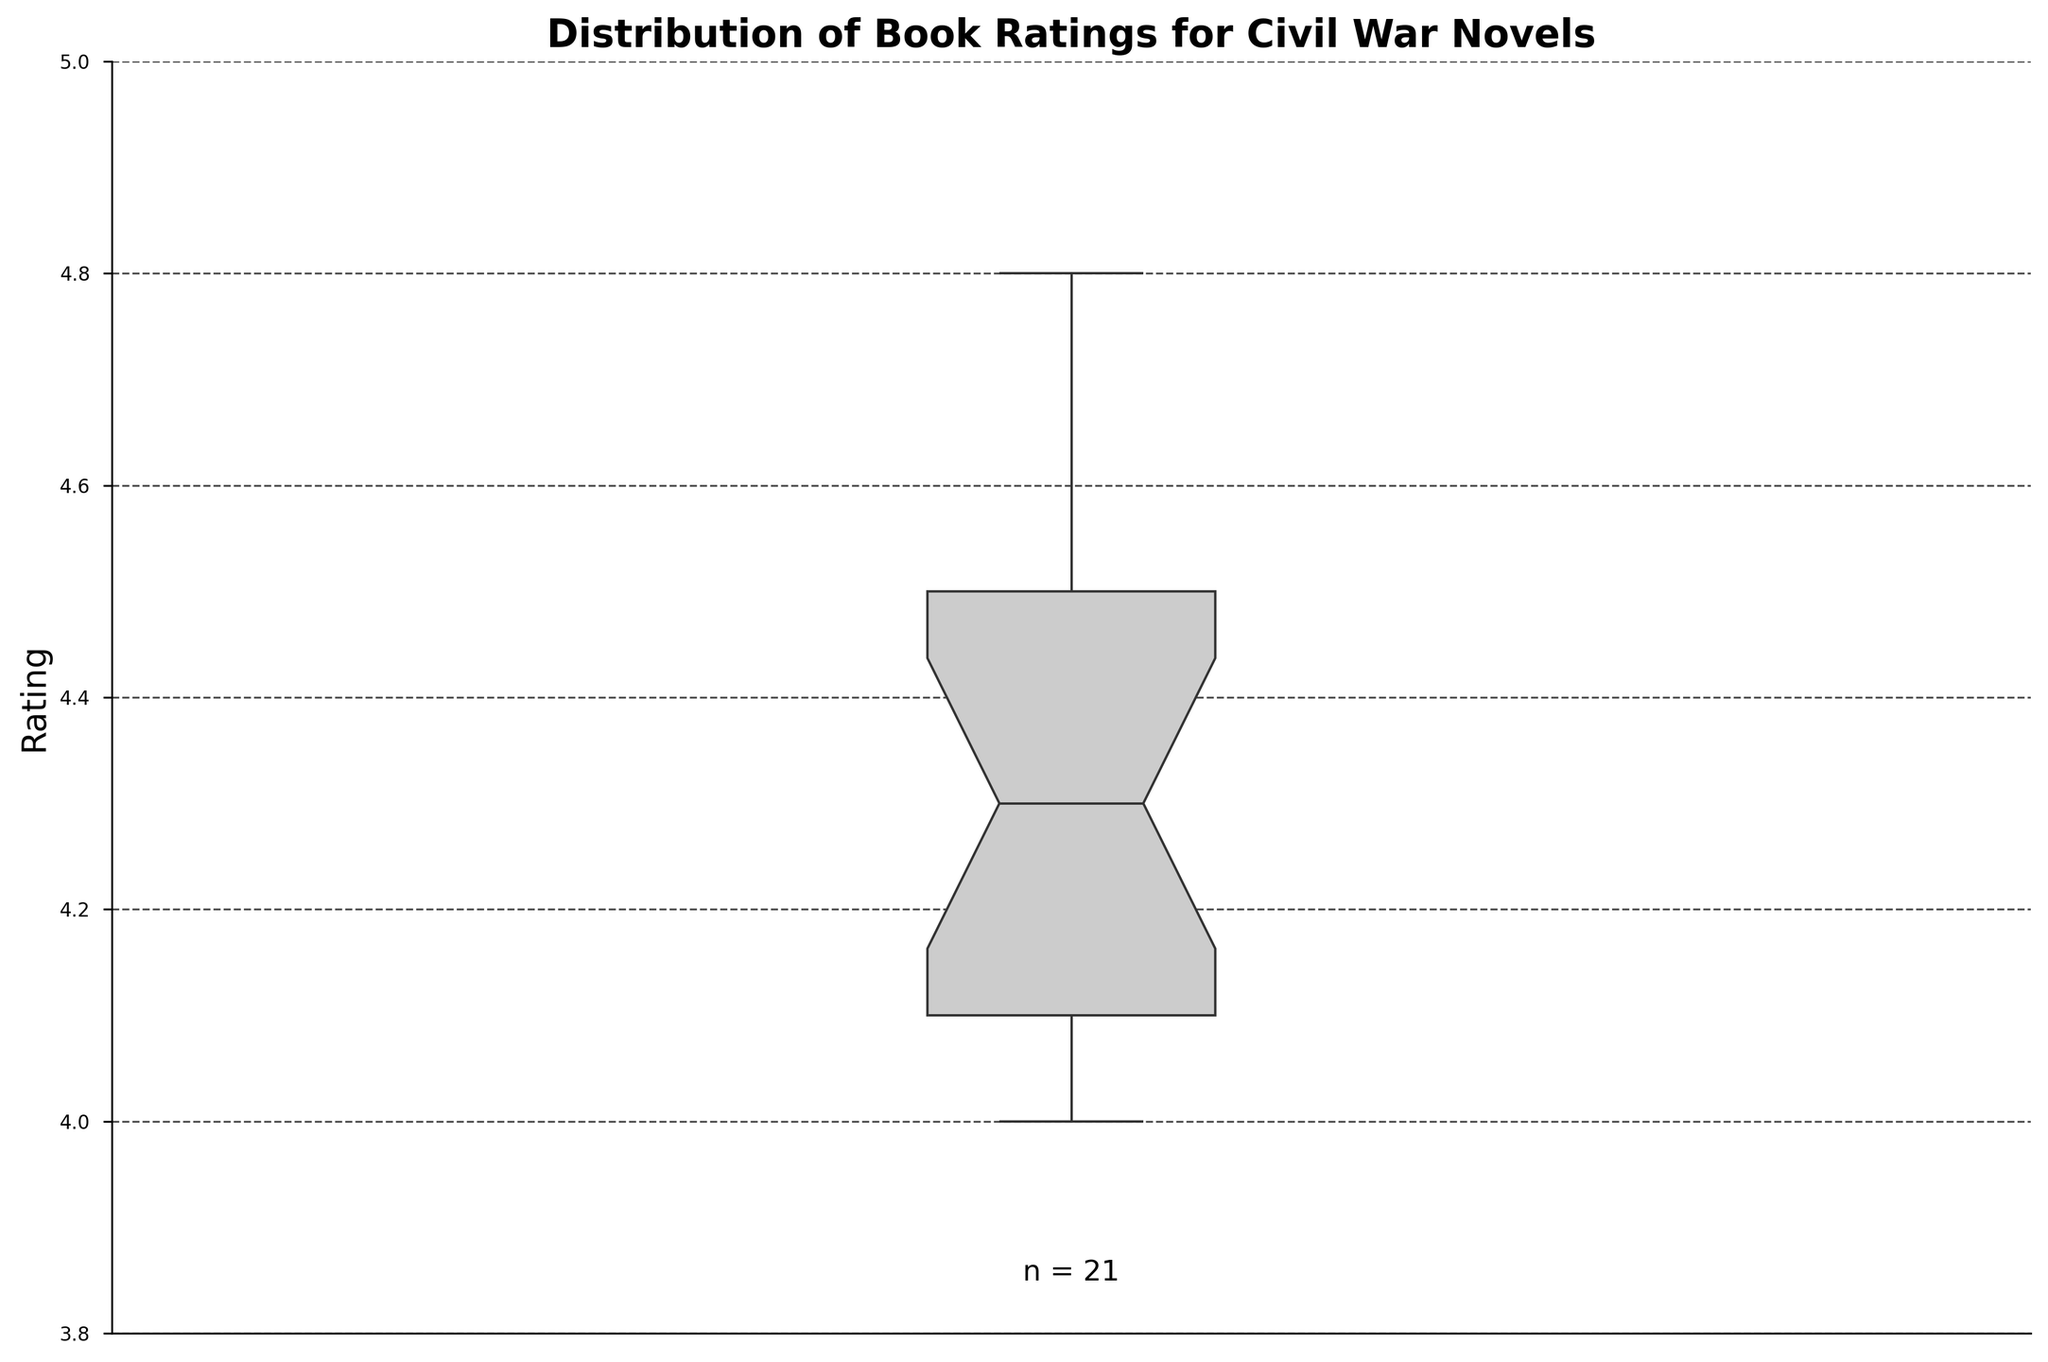What is the title of the figure? The title of the figure is usually placed on top and can be read directly.
Answer: Distribution of Book Ratings for Civil War Novels What is the range of the y-axis? The y-axis range can be observed by looking at the lowest and highest numbers along the axis.
Answer: 3.8 to 5.0 How many books' ratings are represented in the plot? The number of ratings is usually indicated in a notation like "n =", often found near the bottom of the figure.
Answer: 21 What color is used for the box in the box plot? The color of the box can be identified by visually inspecting it.
Answer: Light gray (CCCCCC) What is the median rating of the books? The median is indicated by the line inside the box of the box plot.
Answer: 4.3 What do the notches in the box plot represent? The notches represent a confidence interval around the median and can be used to compare medians; if the notches of different boxes do not overlap, the medians are significantly different.
Answer: Confidence interval around the median What is the interquartile range (IQR) of the book ratings? The interquartile range is found by subtracting the value at the bottom of the box (Q1) from the top of the box (Q3).
Answer: (4.5 - 4.1) = 0.4 Which value has the highest rating for a book and what is it? The highest value can be determined by the top of the whisker or any point above it.
Answer: 4.8 Is there any indication of outliers in the plot? Outliers are typically shown as individual points outside the whiskers.
Answer: No What can you infer about the density of book ratings around the median? The density around the median can be inferred from the width of the box; a thinner box around the median indicates higher density.
Answer: Relatively dense around the median 